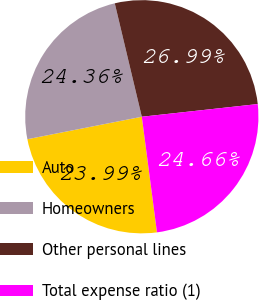<chart> <loc_0><loc_0><loc_500><loc_500><pie_chart><fcel>Auto<fcel>Homeowners<fcel>Other personal lines<fcel>Total expense ratio (1)<nl><fcel>23.99%<fcel>24.36%<fcel>26.99%<fcel>24.66%<nl></chart> 